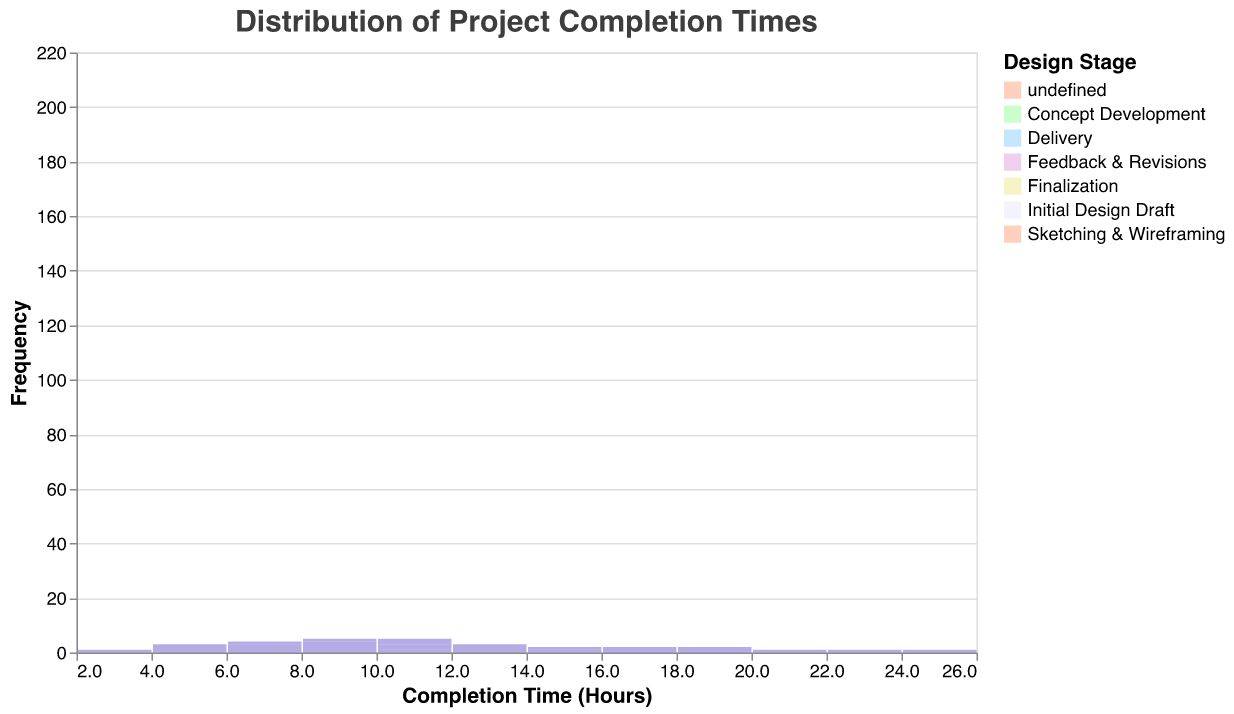What is the title of the figure? The title is positioned at the top of the figure and typically provides a brief description of what the figure represents. In this case, it should clearly state the main focus of the plot.
Answer: Distribution of Project Completion Times What is the x-axis labeled as? The x-axis often represents the variable being measured. In this figure, it represents the completion time in hours.
Answer: Completion Time (Hours) How many total stages are represented in the plot? Each stage in the graphic design process is indicated by a unique color. By counting these distinct colors in the legend, you can determine the number of different stages.
Answer: 6 Which stage appears to have the highest average completion time? The stage with the highest average completion time can be determined by looking at the peak frequency distribution of each stage. The 'Initial Design Draft' stage shows a peak at higher completion hours.
Answer: Initial Design Draft What color represents the 'Delivery' stage? Each stage is represented by a specific color, which is listed in the legend. 'Delivery' corresponds to a yellowish color.
Answer: Yellowish color Which stage has the most data points below 10 hours? To determine which stage has the majority of completion times below 10 hours, we look at the x-axis values less than 10 and see which bars are most frequent and their corresponding stacked color codes.
Answer: Sketching & Wireframing What is the general shape of the distribution curve for 'Feedback & Revisions' stage? The shape of the distribution curve can be inferred from the density line (red) over the histogram bars. Specifically, looking at where this curve peaks and spreads for the 'Feedback & Revisions' color in the bars.
Answer: Bell-shaped (normal distribution) How does the finalization stage compare to the 'Sketching & Wireframing' stage in terms of completion time distribution? By observing the histogram bars, you can see that "Finalization" has more instances towards the lower end of completion times (around 7-10) whereas "Sketching & Wireframing" is more spread out but also towards the lower end (5-10).
Answer: Finalization stage has more compact and generally lower completion times compared to Sketching & Wireframing What is the range of hours for 'Concept Development'? The range can be determined by looking at the spread of the histogram bins where 'Concept Development' data points are present. It spans from the minimum to the maximum completion times.
Answer: 8 - 15 hours 